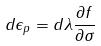Convert formula to latex. <formula><loc_0><loc_0><loc_500><loc_500>d \epsilon _ { p } = d \lambda \frac { \partial f } { \partial \sigma }</formula> 